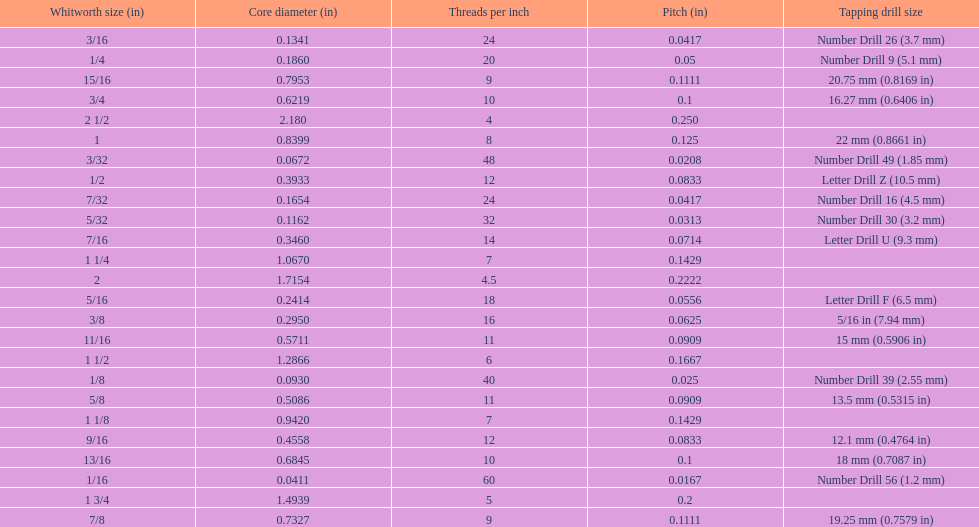Which whitworth size has the same number of threads per inch as 3/16? 7/32. Could you parse the entire table as a dict? {'header': ['Whitworth size (in)', 'Core diameter (in)', 'Threads per\xa0inch', 'Pitch (in)', 'Tapping drill size'], 'rows': [['3/16', '0.1341', '24', '0.0417', 'Number Drill 26 (3.7\xa0mm)'], ['1/4', '0.1860', '20', '0.05', 'Number Drill 9 (5.1\xa0mm)'], ['15/16', '0.7953', '9', '0.1111', '20.75\xa0mm (0.8169\xa0in)'], ['3/4', '0.6219', '10', '0.1', '16.27\xa0mm (0.6406\xa0in)'], ['2 1/2', '2.180', '4', '0.250', ''], ['1', '0.8399', '8', '0.125', '22\xa0mm (0.8661\xa0in)'], ['3/32', '0.0672', '48', '0.0208', 'Number Drill 49 (1.85\xa0mm)'], ['1/2', '0.3933', '12', '0.0833', 'Letter Drill Z (10.5\xa0mm)'], ['7/32', '0.1654', '24', '0.0417', 'Number Drill 16 (4.5\xa0mm)'], ['5/32', '0.1162', '32', '0.0313', 'Number Drill 30 (3.2\xa0mm)'], ['7/16', '0.3460', '14', '0.0714', 'Letter Drill U (9.3\xa0mm)'], ['1 1/4', '1.0670', '7', '0.1429', ''], ['2', '1.7154', '4.5', '0.2222', ''], ['5/16', '0.2414', '18', '0.0556', 'Letter Drill F (6.5\xa0mm)'], ['3/8', '0.2950', '16', '0.0625', '5/16\xa0in (7.94\xa0mm)'], ['11/16', '0.5711', '11', '0.0909', '15\xa0mm (0.5906\xa0in)'], ['1 1/2', '1.2866', '6', '0.1667', ''], ['1/8', '0.0930', '40', '0.025', 'Number Drill 39 (2.55\xa0mm)'], ['5/8', '0.5086', '11', '0.0909', '13.5\xa0mm (0.5315\xa0in)'], ['1 1/8', '0.9420', '7', '0.1429', ''], ['9/16', '0.4558', '12', '0.0833', '12.1\xa0mm (0.4764\xa0in)'], ['13/16', '0.6845', '10', '0.1', '18\xa0mm (0.7087\xa0in)'], ['1/16', '0.0411', '60', '0.0167', 'Number Drill 56 (1.2\xa0mm)'], ['1 3/4', '1.4939', '5', '0.2', ''], ['7/8', '0.7327', '9', '0.1111', '19.25\xa0mm (0.7579\xa0in)']]} 